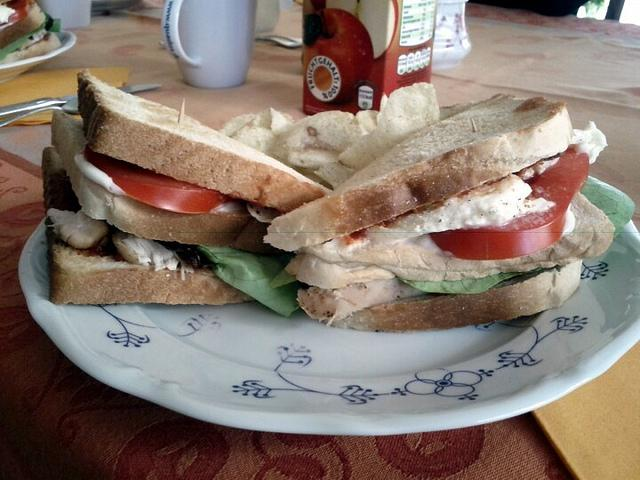What vegetable was used to make the side dish for this sandwich lunch?

Choices:
A) peas
B) endive
C) celery
D) potato potato 